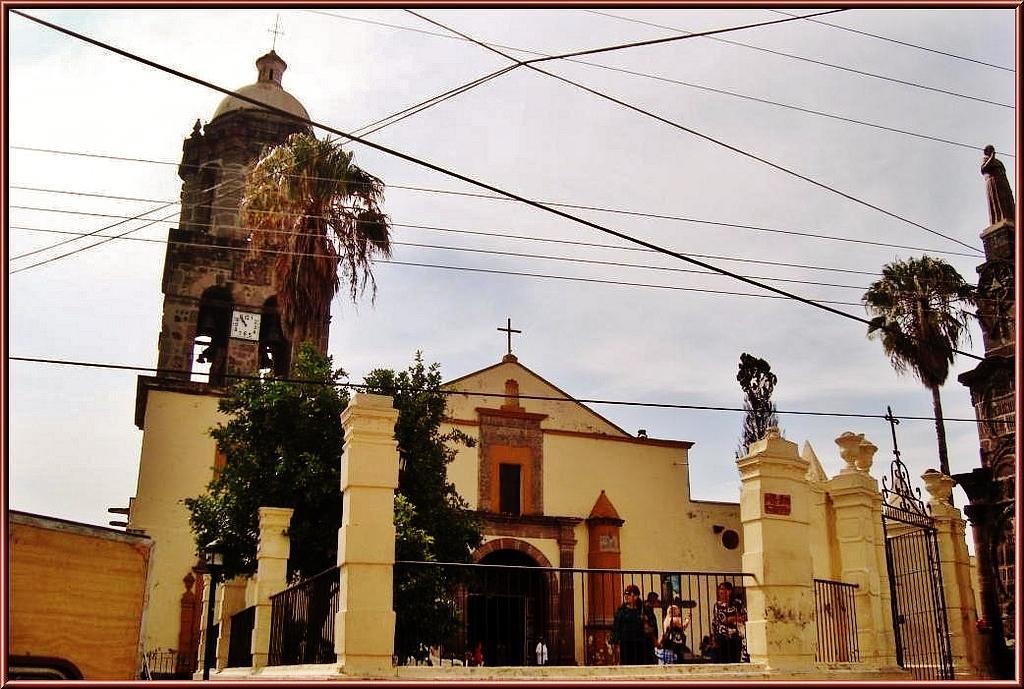Could you give a brief overview of what you see in this image? In the center of the image there is a church and there are people. We can see a grill. In the background there is a tower, trees and sky. At the top there are wires. 